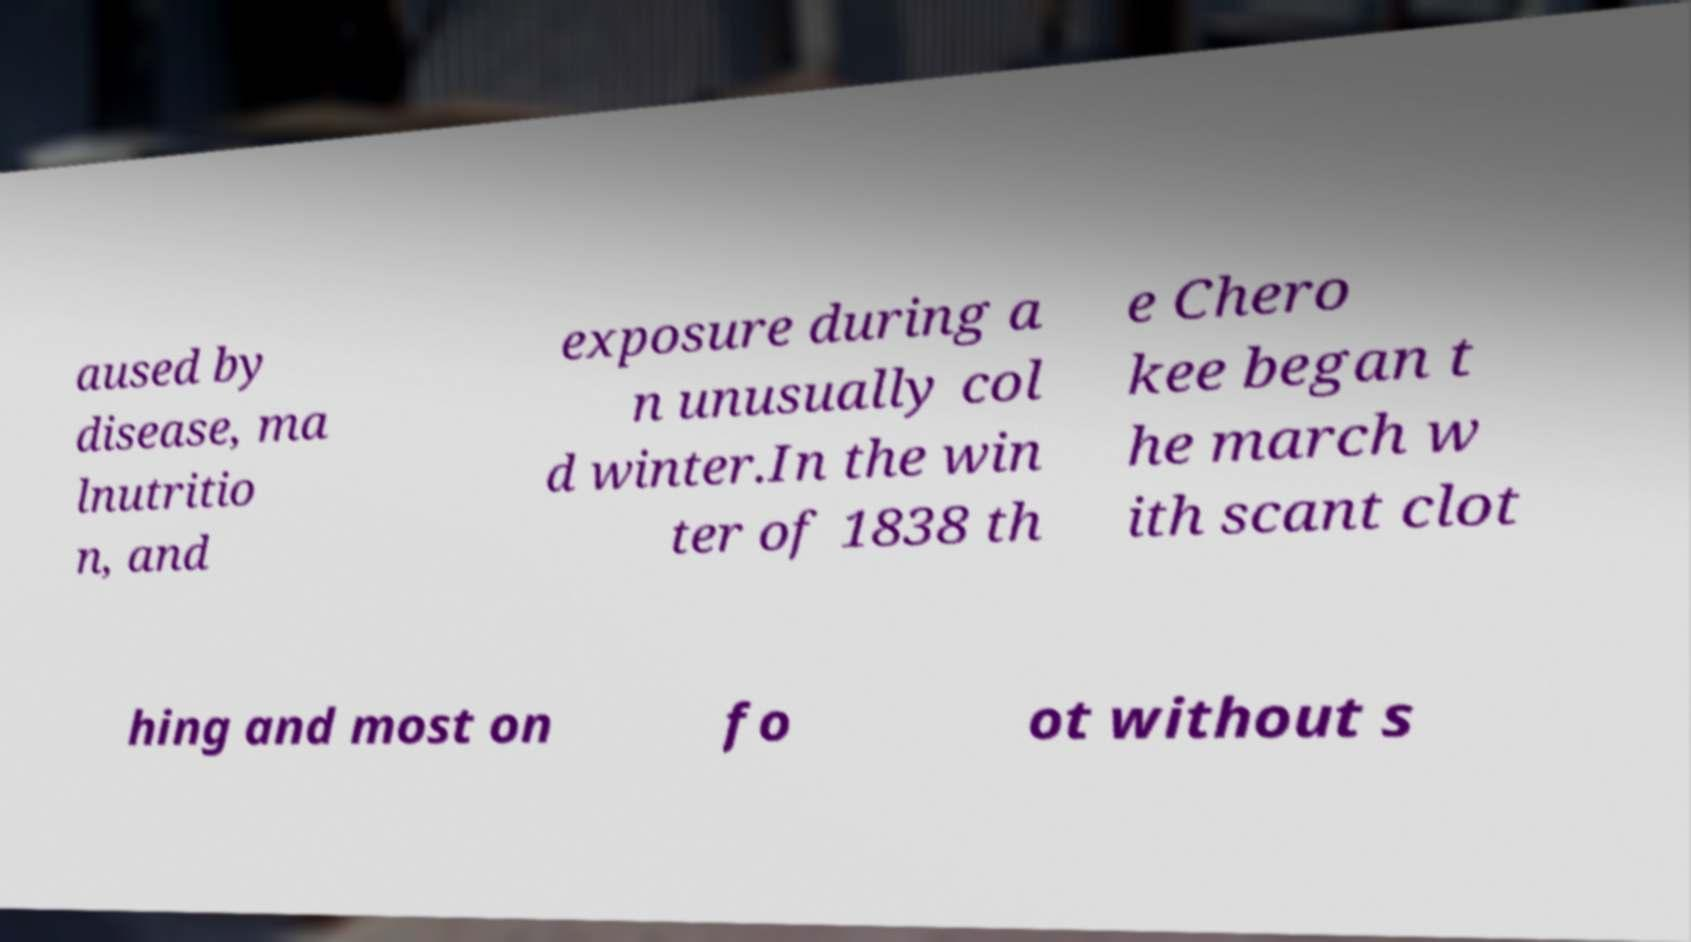Can you accurately transcribe the text from the provided image for me? aused by disease, ma lnutritio n, and exposure during a n unusually col d winter.In the win ter of 1838 th e Chero kee began t he march w ith scant clot hing and most on fo ot without s 